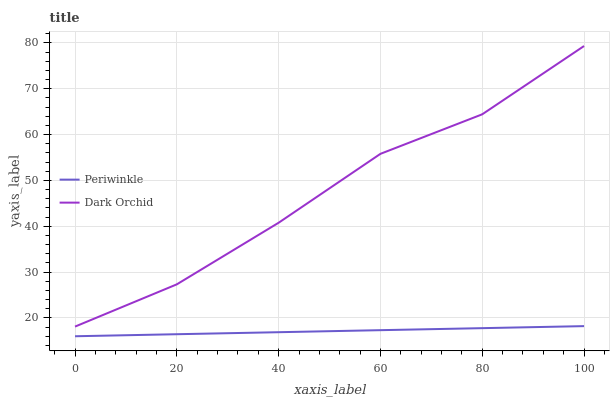Does Periwinkle have the minimum area under the curve?
Answer yes or no. Yes. Does Dark Orchid have the maximum area under the curve?
Answer yes or no. Yes. Does Dark Orchid have the minimum area under the curve?
Answer yes or no. No. Is Periwinkle the smoothest?
Answer yes or no. Yes. Is Dark Orchid the roughest?
Answer yes or no. Yes. Is Dark Orchid the smoothest?
Answer yes or no. No. Does Dark Orchid have the lowest value?
Answer yes or no. No. Is Periwinkle less than Dark Orchid?
Answer yes or no. Yes. Is Dark Orchid greater than Periwinkle?
Answer yes or no. Yes. Does Periwinkle intersect Dark Orchid?
Answer yes or no. No. 